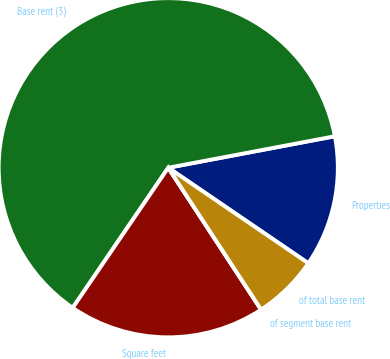Convert chart to OTSL. <chart><loc_0><loc_0><loc_500><loc_500><pie_chart><fcel>Properties<fcel>Base rent (3)<fcel>Square feet<fcel>of segment base rent<fcel>of total base rent<nl><fcel>12.5%<fcel>62.5%<fcel>18.75%<fcel>0.0%<fcel>6.25%<nl></chart> 